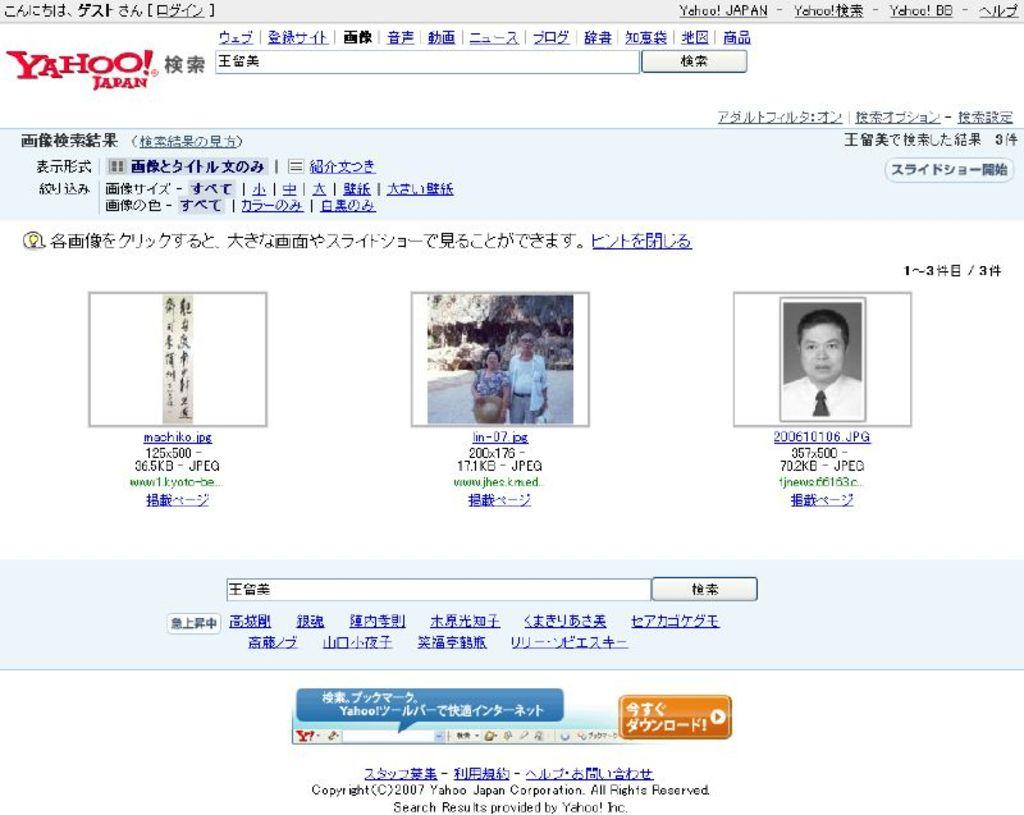What type of image is shown in the screenshot? The image is a screenshot of a web page. What can be found on the web page besides text? There are images on the web page. What information is provided on the web page? There is text on the web page. Who is the owner of the mask shown in the image? There is no mask present in the image, so it is not possible to determine the owner. 